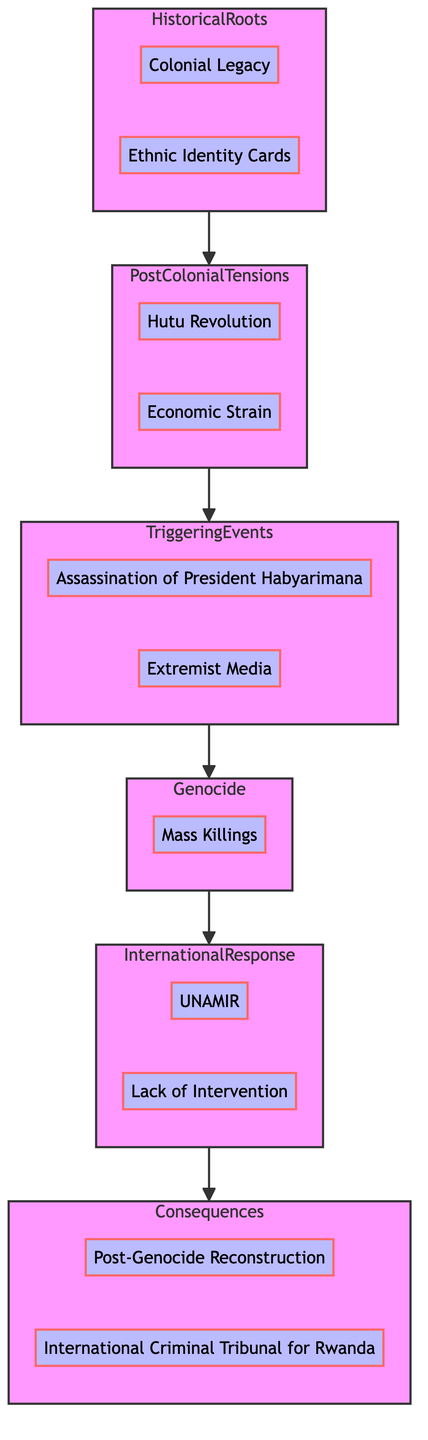What is the first stage in the flow chart? The flow chart begins at the bottom with the stage labeled "Historical Roots."
Answer: Historical Roots How many elements are in the "International Response" stage? The "International Response" stage contains two elements: "UNAMIR" and "Lack of Intervention."
Answer: 2 Which stage follows "Post-Colonial Tensions"? The stage that follows "Post-Colonial Tensions" is "Triggering Events."
Answer: Triggering Events What is a consequence listed in the diagram? The diagram lists "Post-Genocide Reconstruction" and "International Criminal Tribunal for Rwanda" as consequences.
Answer: Post-Genocide Reconstruction What event triggered the genocide according to the diagram? The assassination of President Habyarimana is identified as a key triggering event that led to the genocide.
Answer: Assassination of President Habyarimana How does the "Genocide" stage connect to the "International Response" stage? The "Genocide" stage connects to the "International Response" stage, indicating that the genocide prompted an international reaction.
Answer: Genocide to International Response Which stage includes both "Hutu Revolution" and "Economic Strain"? The stage that includes both "Hutu Revolution" and "Economic Strain" is "Post-Colonial Tensions."
Answer: Post-Colonial Tensions How many stages are in the flow chart? The flow chart consists of five distinct stages: "Historical Roots," "Post-Colonial Tensions," "Triggering Events," "Genocide," and "International Response," leading up to "Consequences."
Answer: 5 What is the final stage in the flow chart? The final stage at the top of the flow chart is "Consequences."
Answer: Consequences 